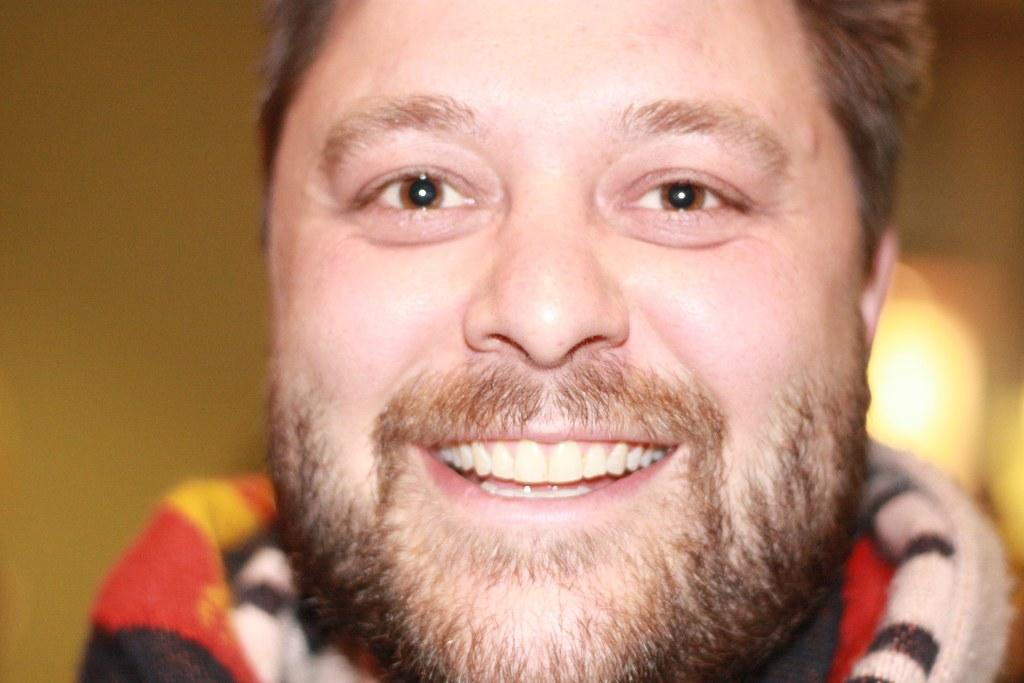What is the main subject of the image? The main subject of the image is a person. What expression does the person have? The person is smiling. Can you describe the background of the image? The background of the image is blurred. How fast is the person running in the image? There is no indication of the person running in the image; they are simply smiling. What type of knife is being used by the person in the image? There is no knife present in the image. 